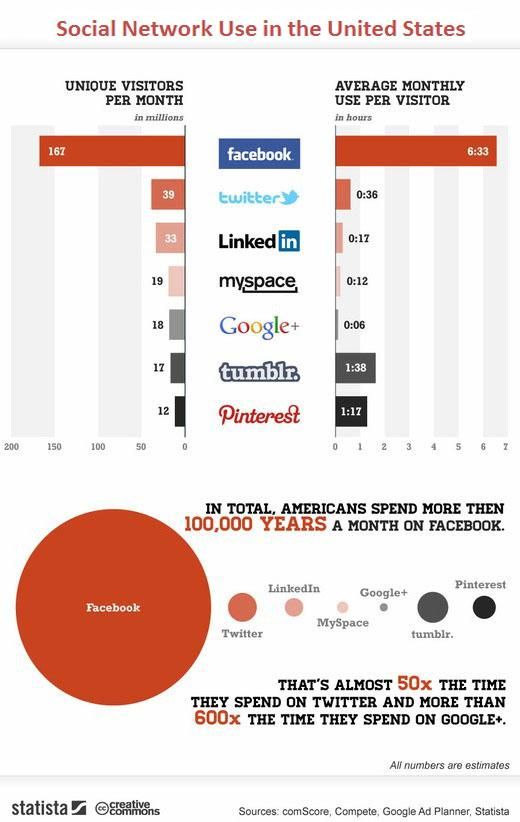Indicate a few pertinent items in this graphic. Twitter is the second most widely used social networking site per month. According to data, MySpace is the second least used social networking site in the United States, with the lowest number of visitors compared to other sites in the same category. Tumblr is the second least used social networking site per month. The Facebook logo background color in the bar chart is blue. Tumblr is the second most frequently used social networking site in the United States, in terms of visitor traffic. 